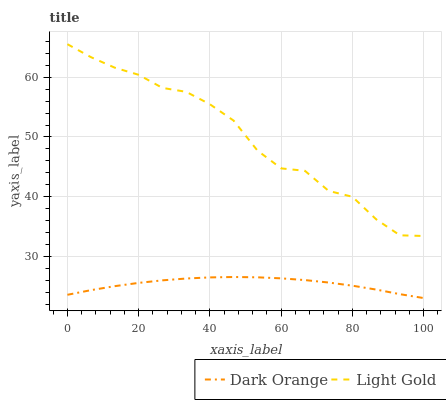Does Dark Orange have the minimum area under the curve?
Answer yes or no. Yes. Does Light Gold have the maximum area under the curve?
Answer yes or no. Yes. Does Light Gold have the minimum area under the curve?
Answer yes or no. No. Is Dark Orange the smoothest?
Answer yes or no. Yes. Is Light Gold the roughest?
Answer yes or no. Yes. Is Light Gold the smoothest?
Answer yes or no. No. Does Dark Orange have the lowest value?
Answer yes or no. Yes. Does Light Gold have the lowest value?
Answer yes or no. No. Does Light Gold have the highest value?
Answer yes or no. Yes. Is Dark Orange less than Light Gold?
Answer yes or no. Yes. Is Light Gold greater than Dark Orange?
Answer yes or no. Yes. Does Dark Orange intersect Light Gold?
Answer yes or no. No. 